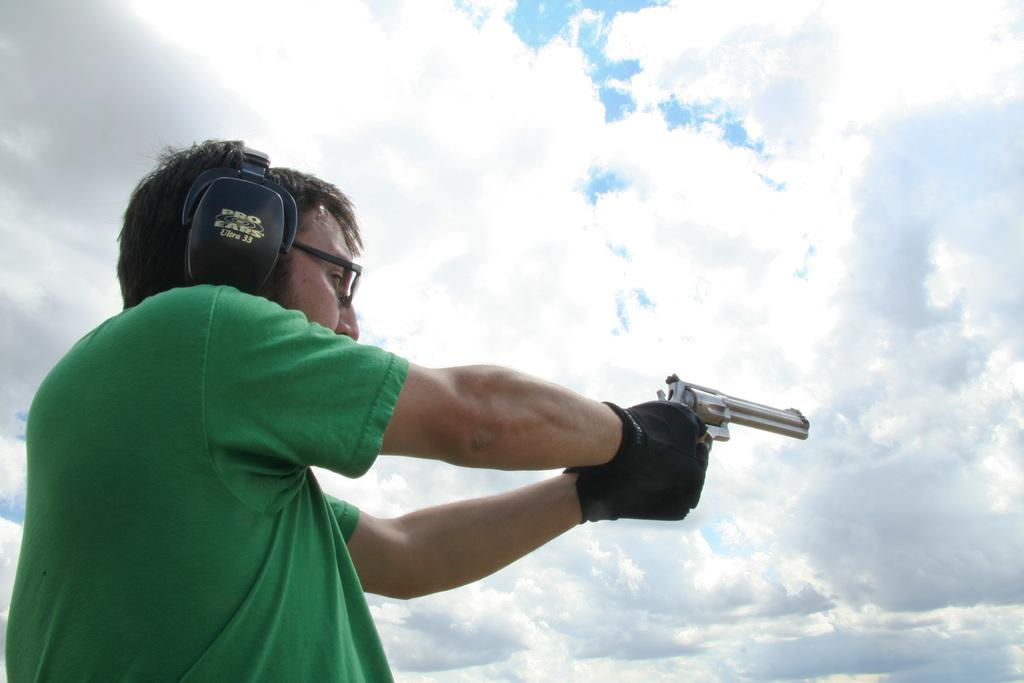What is the main subject of the image? There is a person in the image. What is the person holding in his hands? The person is holding a gun in his hands. What can be seen in the background of the image? There are clouds in the sky in the background of the image. How many snails can be seen crawling on the person's arm in the image? There are no snails visible in the image. What type of horn is the person using to communicate in the image? There is no horn present in the image. 